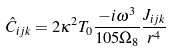<formula> <loc_0><loc_0><loc_500><loc_500>\hat { C } _ { i j k } = 2 \kappa ^ { 2 } T _ { 0 } \frac { - i \omega ^ { 3 } } { 1 0 5 \Omega _ { 8 } } \frac { J _ { i j k } } { r ^ { 4 } }</formula> 